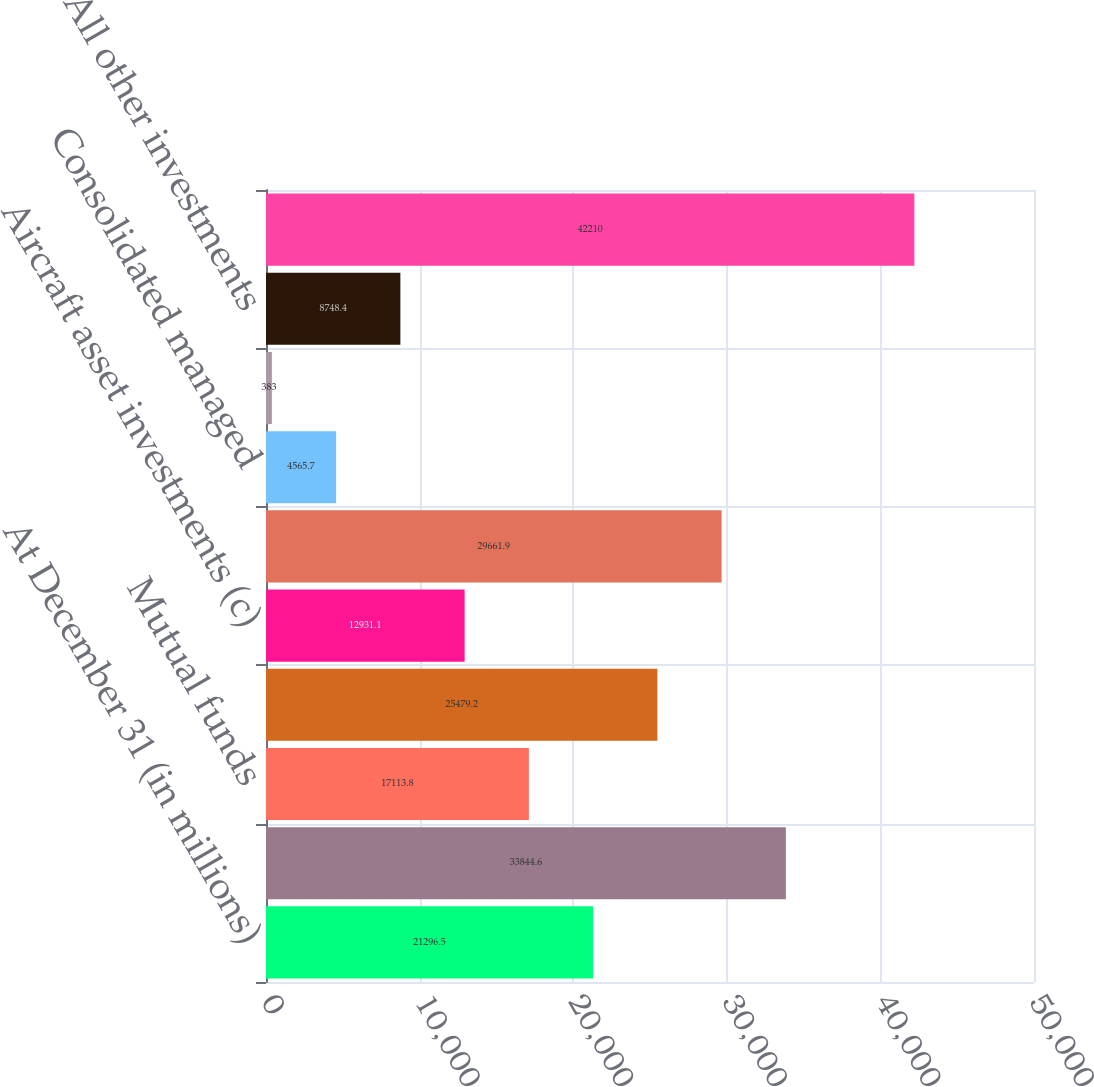Convert chart. <chart><loc_0><loc_0><loc_500><loc_500><bar_chart><fcel>At December 31 (in millions)<fcel>Alternative funds (a)<fcel>Mutual funds<fcel>Investment real estate (b)<fcel>Aircraft asset investments (c)<fcel>Life settlement contracts<fcel>Consolidated managed<fcel>Direct private equity<fcel>All other investments<fcel>Other invested assets<nl><fcel>21296.5<fcel>33844.6<fcel>17113.8<fcel>25479.2<fcel>12931.1<fcel>29661.9<fcel>4565.7<fcel>383<fcel>8748.4<fcel>42210<nl></chart> 